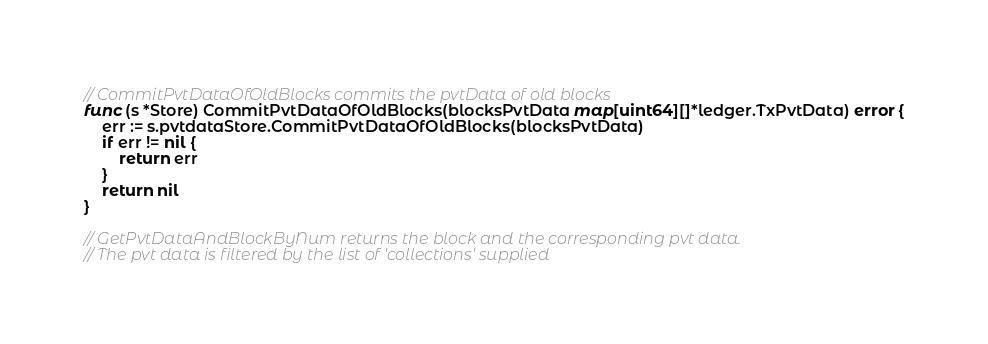<code> <loc_0><loc_0><loc_500><loc_500><_Go_>// CommitPvtDataOfOldBlocks commits the pvtData of old blocks
func (s *Store) CommitPvtDataOfOldBlocks(blocksPvtData map[uint64][]*ledger.TxPvtData) error {
	err := s.pvtdataStore.CommitPvtDataOfOldBlocks(blocksPvtData)
	if err != nil {
		return err
	}
	return nil
}

// GetPvtDataAndBlockByNum returns the block and the corresponding pvt data.
// The pvt data is filtered by the list of 'collections' supplied</code> 